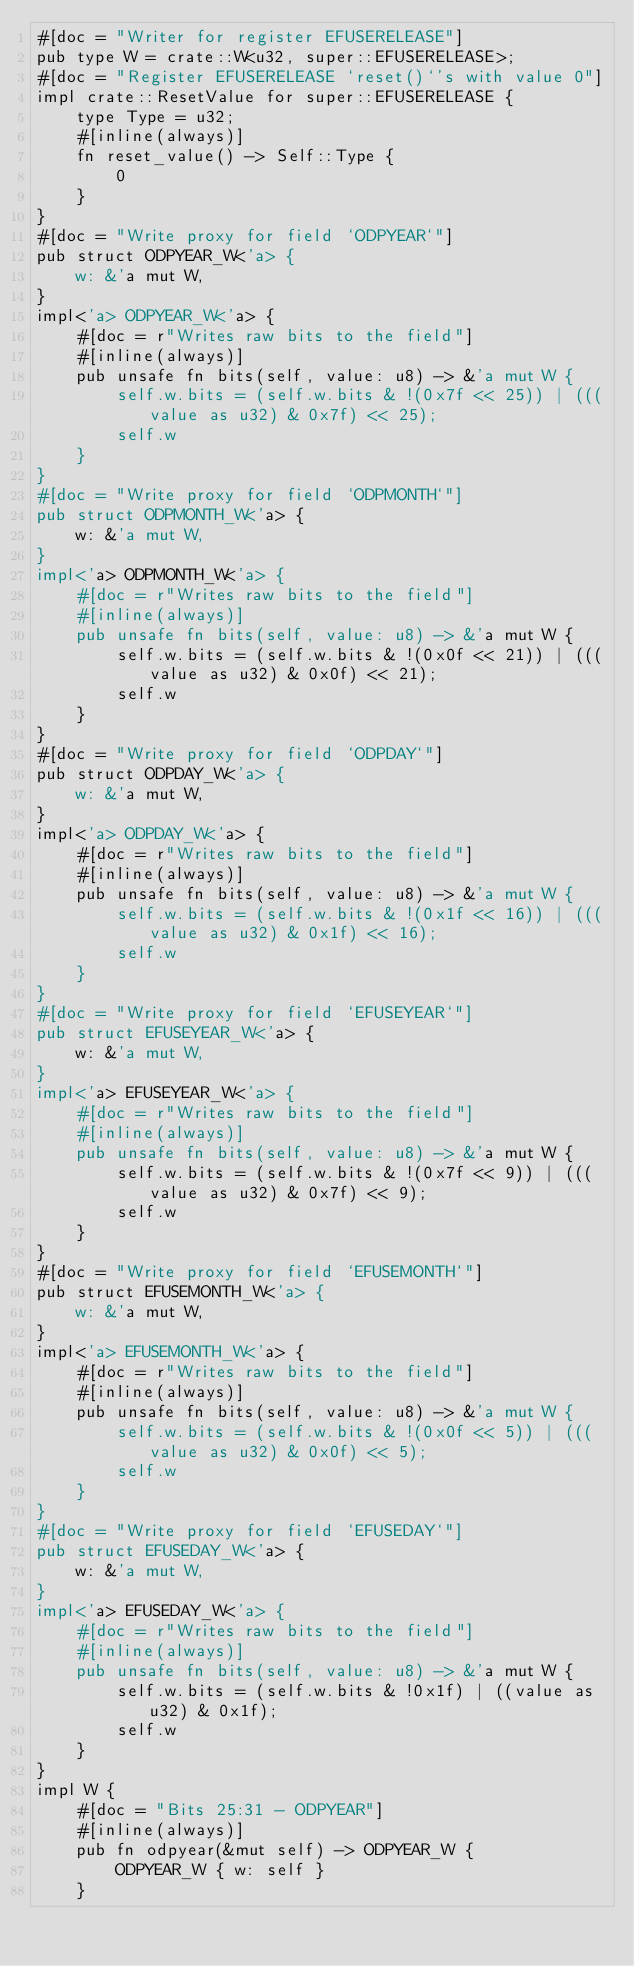<code> <loc_0><loc_0><loc_500><loc_500><_Rust_>#[doc = "Writer for register EFUSERELEASE"]
pub type W = crate::W<u32, super::EFUSERELEASE>;
#[doc = "Register EFUSERELEASE `reset()`'s with value 0"]
impl crate::ResetValue for super::EFUSERELEASE {
    type Type = u32;
    #[inline(always)]
    fn reset_value() -> Self::Type {
        0
    }
}
#[doc = "Write proxy for field `ODPYEAR`"]
pub struct ODPYEAR_W<'a> {
    w: &'a mut W,
}
impl<'a> ODPYEAR_W<'a> {
    #[doc = r"Writes raw bits to the field"]
    #[inline(always)]
    pub unsafe fn bits(self, value: u8) -> &'a mut W {
        self.w.bits = (self.w.bits & !(0x7f << 25)) | (((value as u32) & 0x7f) << 25);
        self.w
    }
}
#[doc = "Write proxy for field `ODPMONTH`"]
pub struct ODPMONTH_W<'a> {
    w: &'a mut W,
}
impl<'a> ODPMONTH_W<'a> {
    #[doc = r"Writes raw bits to the field"]
    #[inline(always)]
    pub unsafe fn bits(self, value: u8) -> &'a mut W {
        self.w.bits = (self.w.bits & !(0x0f << 21)) | (((value as u32) & 0x0f) << 21);
        self.w
    }
}
#[doc = "Write proxy for field `ODPDAY`"]
pub struct ODPDAY_W<'a> {
    w: &'a mut W,
}
impl<'a> ODPDAY_W<'a> {
    #[doc = r"Writes raw bits to the field"]
    #[inline(always)]
    pub unsafe fn bits(self, value: u8) -> &'a mut W {
        self.w.bits = (self.w.bits & !(0x1f << 16)) | (((value as u32) & 0x1f) << 16);
        self.w
    }
}
#[doc = "Write proxy for field `EFUSEYEAR`"]
pub struct EFUSEYEAR_W<'a> {
    w: &'a mut W,
}
impl<'a> EFUSEYEAR_W<'a> {
    #[doc = r"Writes raw bits to the field"]
    #[inline(always)]
    pub unsafe fn bits(self, value: u8) -> &'a mut W {
        self.w.bits = (self.w.bits & !(0x7f << 9)) | (((value as u32) & 0x7f) << 9);
        self.w
    }
}
#[doc = "Write proxy for field `EFUSEMONTH`"]
pub struct EFUSEMONTH_W<'a> {
    w: &'a mut W,
}
impl<'a> EFUSEMONTH_W<'a> {
    #[doc = r"Writes raw bits to the field"]
    #[inline(always)]
    pub unsafe fn bits(self, value: u8) -> &'a mut W {
        self.w.bits = (self.w.bits & !(0x0f << 5)) | (((value as u32) & 0x0f) << 5);
        self.w
    }
}
#[doc = "Write proxy for field `EFUSEDAY`"]
pub struct EFUSEDAY_W<'a> {
    w: &'a mut W,
}
impl<'a> EFUSEDAY_W<'a> {
    #[doc = r"Writes raw bits to the field"]
    #[inline(always)]
    pub unsafe fn bits(self, value: u8) -> &'a mut W {
        self.w.bits = (self.w.bits & !0x1f) | ((value as u32) & 0x1f);
        self.w
    }
}
impl W {
    #[doc = "Bits 25:31 - ODPYEAR"]
    #[inline(always)]
    pub fn odpyear(&mut self) -> ODPYEAR_W {
        ODPYEAR_W { w: self }
    }</code> 